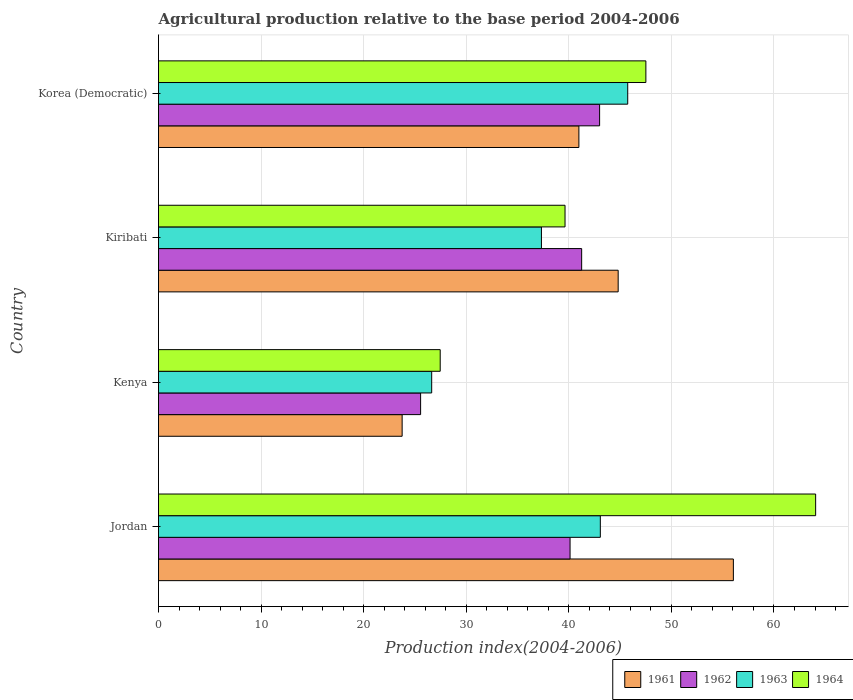How many groups of bars are there?
Give a very brief answer. 4. Are the number of bars on each tick of the Y-axis equal?
Keep it short and to the point. Yes. How many bars are there on the 4th tick from the top?
Provide a short and direct response. 4. What is the label of the 4th group of bars from the top?
Give a very brief answer. Jordan. What is the agricultural production index in 1961 in Kiribati?
Make the answer very short. 44.81. Across all countries, what is the maximum agricultural production index in 1962?
Your answer should be compact. 43. Across all countries, what is the minimum agricultural production index in 1963?
Your response must be concise. 26.63. In which country was the agricultural production index in 1962 maximum?
Make the answer very short. Korea (Democratic). In which country was the agricultural production index in 1962 minimum?
Offer a terse response. Kenya. What is the total agricultural production index in 1964 in the graph?
Your answer should be compact. 178.66. What is the difference between the agricultural production index in 1961 in Jordan and that in Kenya?
Offer a terse response. 32.29. What is the difference between the agricultural production index in 1962 in Kiribati and the agricultural production index in 1964 in Korea (Democratic)?
Provide a short and direct response. -6.26. What is the average agricultural production index in 1961 per country?
Provide a succinct answer. 41.39. What is the difference between the agricultural production index in 1963 and agricultural production index in 1964 in Kiribati?
Your response must be concise. -2.3. In how many countries, is the agricultural production index in 1961 greater than 36 ?
Offer a terse response. 3. What is the ratio of the agricultural production index in 1964 in Kiribati to that in Korea (Democratic)?
Make the answer very short. 0.83. Is the agricultural production index in 1961 in Kenya less than that in Korea (Democratic)?
Provide a short and direct response. Yes. Is the difference between the agricultural production index in 1963 in Kiribati and Korea (Democratic) greater than the difference between the agricultural production index in 1964 in Kiribati and Korea (Democratic)?
Provide a succinct answer. No. What is the difference between the highest and the second highest agricultural production index in 1961?
Make the answer very short. 11.23. What is the difference between the highest and the lowest agricultural production index in 1964?
Provide a short and direct response. 36.6. In how many countries, is the agricultural production index in 1964 greater than the average agricultural production index in 1964 taken over all countries?
Give a very brief answer. 2. Is the sum of the agricultural production index in 1962 in Jordan and Korea (Democratic) greater than the maximum agricultural production index in 1963 across all countries?
Offer a very short reply. Yes. What does the 1st bar from the top in Jordan represents?
Offer a very short reply. 1964. What does the 4th bar from the bottom in Kenya represents?
Give a very brief answer. 1964. Is it the case that in every country, the sum of the agricultural production index in 1961 and agricultural production index in 1963 is greater than the agricultural production index in 1964?
Your answer should be compact. Yes. How many bars are there?
Provide a succinct answer. 16. How many countries are there in the graph?
Offer a terse response. 4. Are the values on the major ticks of X-axis written in scientific E-notation?
Make the answer very short. No. Does the graph contain any zero values?
Provide a succinct answer. No. Does the graph contain grids?
Ensure brevity in your answer.  Yes. Where does the legend appear in the graph?
Keep it short and to the point. Bottom right. How many legend labels are there?
Your answer should be very brief. 4. What is the title of the graph?
Ensure brevity in your answer.  Agricultural production relative to the base period 2004-2006. What is the label or title of the X-axis?
Keep it short and to the point. Production index(2004-2006). What is the label or title of the Y-axis?
Provide a short and direct response. Country. What is the Production index(2004-2006) in 1961 in Jordan?
Provide a succinct answer. 56.04. What is the Production index(2004-2006) of 1962 in Jordan?
Ensure brevity in your answer.  40.12. What is the Production index(2004-2006) of 1963 in Jordan?
Ensure brevity in your answer.  43.07. What is the Production index(2004-2006) of 1964 in Jordan?
Ensure brevity in your answer.  64.06. What is the Production index(2004-2006) in 1961 in Kenya?
Provide a succinct answer. 23.75. What is the Production index(2004-2006) in 1962 in Kenya?
Ensure brevity in your answer.  25.55. What is the Production index(2004-2006) in 1963 in Kenya?
Provide a succinct answer. 26.63. What is the Production index(2004-2006) of 1964 in Kenya?
Your answer should be compact. 27.46. What is the Production index(2004-2006) in 1961 in Kiribati?
Your answer should be very brief. 44.81. What is the Production index(2004-2006) in 1962 in Kiribati?
Your answer should be very brief. 41.25. What is the Production index(2004-2006) in 1963 in Kiribati?
Provide a succinct answer. 37.33. What is the Production index(2004-2006) in 1964 in Kiribati?
Your response must be concise. 39.63. What is the Production index(2004-2006) of 1961 in Korea (Democratic)?
Your response must be concise. 40.98. What is the Production index(2004-2006) of 1963 in Korea (Democratic)?
Your answer should be compact. 45.74. What is the Production index(2004-2006) in 1964 in Korea (Democratic)?
Your response must be concise. 47.51. Across all countries, what is the maximum Production index(2004-2006) of 1961?
Offer a terse response. 56.04. Across all countries, what is the maximum Production index(2004-2006) in 1962?
Offer a very short reply. 43. Across all countries, what is the maximum Production index(2004-2006) of 1963?
Ensure brevity in your answer.  45.74. Across all countries, what is the maximum Production index(2004-2006) in 1964?
Offer a terse response. 64.06. Across all countries, what is the minimum Production index(2004-2006) of 1961?
Offer a terse response. 23.75. Across all countries, what is the minimum Production index(2004-2006) in 1962?
Provide a short and direct response. 25.55. Across all countries, what is the minimum Production index(2004-2006) in 1963?
Ensure brevity in your answer.  26.63. Across all countries, what is the minimum Production index(2004-2006) in 1964?
Make the answer very short. 27.46. What is the total Production index(2004-2006) of 1961 in the graph?
Your response must be concise. 165.58. What is the total Production index(2004-2006) of 1962 in the graph?
Offer a very short reply. 149.92. What is the total Production index(2004-2006) of 1963 in the graph?
Your answer should be compact. 152.77. What is the total Production index(2004-2006) in 1964 in the graph?
Your answer should be compact. 178.66. What is the difference between the Production index(2004-2006) in 1961 in Jordan and that in Kenya?
Your response must be concise. 32.29. What is the difference between the Production index(2004-2006) of 1962 in Jordan and that in Kenya?
Your answer should be compact. 14.57. What is the difference between the Production index(2004-2006) of 1963 in Jordan and that in Kenya?
Ensure brevity in your answer.  16.44. What is the difference between the Production index(2004-2006) of 1964 in Jordan and that in Kenya?
Ensure brevity in your answer.  36.6. What is the difference between the Production index(2004-2006) in 1961 in Jordan and that in Kiribati?
Make the answer very short. 11.23. What is the difference between the Production index(2004-2006) of 1962 in Jordan and that in Kiribati?
Your answer should be compact. -1.13. What is the difference between the Production index(2004-2006) in 1963 in Jordan and that in Kiribati?
Offer a very short reply. 5.74. What is the difference between the Production index(2004-2006) in 1964 in Jordan and that in Kiribati?
Keep it short and to the point. 24.43. What is the difference between the Production index(2004-2006) in 1961 in Jordan and that in Korea (Democratic)?
Your response must be concise. 15.06. What is the difference between the Production index(2004-2006) of 1962 in Jordan and that in Korea (Democratic)?
Offer a very short reply. -2.88. What is the difference between the Production index(2004-2006) of 1963 in Jordan and that in Korea (Democratic)?
Give a very brief answer. -2.67. What is the difference between the Production index(2004-2006) of 1964 in Jordan and that in Korea (Democratic)?
Give a very brief answer. 16.55. What is the difference between the Production index(2004-2006) of 1961 in Kenya and that in Kiribati?
Offer a terse response. -21.06. What is the difference between the Production index(2004-2006) of 1962 in Kenya and that in Kiribati?
Ensure brevity in your answer.  -15.7. What is the difference between the Production index(2004-2006) in 1964 in Kenya and that in Kiribati?
Offer a terse response. -12.17. What is the difference between the Production index(2004-2006) of 1961 in Kenya and that in Korea (Democratic)?
Offer a very short reply. -17.23. What is the difference between the Production index(2004-2006) of 1962 in Kenya and that in Korea (Democratic)?
Your answer should be compact. -17.45. What is the difference between the Production index(2004-2006) in 1963 in Kenya and that in Korea (Democratic)?
Keep it short and to the point. -19.11. What is the difference between the Production index(2004-2006) of 1964 in Kenya and that in Korea (Democratic)?
Your response must be concise. -20.05. What is the difference between the Production index(2004-2006) in 1961 in Kiribati and that in Korea (Democratic)?
Provide a succinct answer. 3.83. What is the difference between the Production index(2004-2006) of 1962 in Kiribati and that in Korea (Democratic)?
Your answer should be compact. -1.75. What is the difference between the Production index(2004-2006) in 1963 in Kiribati and that in Korea (Democratic)?
Ensure brevity in your answer.  -8.41. What is the difference between the Production index(2004-2006) in 1964 in Kiribati and that in Korea (Democratic)?
Keep it short and to the point. -7.88. What is the difference between the Production index(2004-2006) in 1961 in Jordan and the Production index(2004-2006) in 1962 in Kenya?
Your response must be concise. 30.49. What is the difference between the Production index(2004-2006) of 1961 in Jordan and the Production index(2004-2006) of 1963 in Kenya?
Offer a terse response. 29.41. What is the difference between the Production index(2004-2006) in 1961 in Jordan and the Production index(2004-2006) in 1964 in Kenya?
Make the answer very short. 28.58. What is the difference between the Production index(2004-2006) of 1962 in Jordan and the Production index(2004-2006) of 1963 in Kenya?
Make the answer very short. 13.49. What is the difference between the Production index(2004-2006) in 1962 in Jordan and the Production index(2004-2006) in 1964 in Kenya?
Keep it short and to the point. 12.66. What is the difference between the Production index(2004-2006) in 1963 in Jordan and the Production index(2004-2006) in 1964 in Kenya?
Your response must be concise. 15.61. What is the difference between the Production index(2004-2006) in 1961 in Jordan and the Production index(2004-2006) in 1962 in Kiribati?
Provide a short and direct response. 14.79. What is the difference between the Production index(2004-2006) of 1961 in Jordan and the Production index(2004-2006) of 1963 in Kiribati?
Provide a succinct answer. 18.71. What is the difference between the Production index(2004-2006) in 1961 in Jordan and the Production index(2004-2006) in 1964 in Kiribati?
Offer a terse response. 16.41. What is the difference between the Production index(2004-2006) in 1962 in Jordan and the Production index(2004-2006) in 1963 in Kiribati?
Your answer should be compact. 2.79. What is the difference between the Production index(2004-2006) of 1962 in Jordan and the Production index(2004-2006) of 1964 in Kiribati?
Keep it short and to the point. 0.49. What is the difference between the Production index(2004-2006) in 1963 in Jordan and the Production index(2004-2006) in 1964 in Kiribati?
Ensure brevity in your answer.  3.44. What is the difference between the Production index(2004-2006) in 1961 in Jordan and the Production index(2004-2006) in 1962 in Korea (Democratic)?
Offer a terse response. 13.04. What is the difference between the Production index(2004-2006) in 1961 in Jordan and the Production index(2004-2006) in 1963 in Korea (Democratic)?
Make the answer very short. 10.3. What is the difference between the Production index(2004-2006) of 1961 in Jordan and the Production index(2004-2006) of 1964 in Korea (Democratic)?
Keep it short and to the point. 8.53. What is the difference between the Production index(2004-2006) of 1962 in Jordan and the Production index(2004-2006) of 1963 in Korea (Democratic)?
Give a very brief answer. -5.62. What is the difference between the Production index(2004-2006) of 1962 in Jordan and the Production index(2004-2006) of 1964 in Korea (Democratic)?
Keep it short and to the point. -7.39. What is the difference between the Production index(2004-2006) of 1963 in Jordan and the Production index(2004-2006) of 1964 in Korea (Democratic)?
Your response must be concise. -4.44. What is the difference between the Production index(2004-2006) of 1961 in Kenya and the Production index(2004-2006) of 1962 in Kiribati?
Your response must be concise. -17.5. What is the difference between the Production index(2004-2006) of 1961 in Kenya and the Production index(2004-2006) of 1963 in Kiribati?
Your answer should be very brief. -13.58. What is the difference between the Production index(2004-2006) in 1961 in Kenya and the Production index(2004-2006) in 1964 in Kiribati?
Provide a short and direct response. -15.88. What is the difference between the Production index(2004-2006) in 1962 in Kenya and the Production index(2004-2006) in 1963 in Kiribati?
Offer a very short reply. -11.78. What is the difference between the Production index(2004-2006) of 1962 in Kenya and the Production index(2004-2006) of 1964 in Kiribati?
Offer a terse response. -14.08. What is the difference between the Production index(2004-2006) in 1963 in Kenya and the Production index(2004-2006) in 1964 in Kiribati?
Ensure brevity in your answer.  -13. What is the difference between the Production index(2004-2006) in 1961 in Kenya and the Production index(2004-2006) in 1962 in Korea (Democratic)?
Offer a terse response. -19.25. What is the difference between the Production index(2004-2006) in 1961 in Kenya and the Production index(2004-2006) in 1963 in Korea (Democratic)?
Provide a succinct answer. -21.99. What is the difference between the Production index(2004-2006) in 1961 in Kenya and the Production index(2004-2006) in 1964 in Korea (Democratic)?
Ensure brevity in your answer.  -23.76. What is the difference between the Production index(2004-2006) of 1962 in Kenya and the Production index(2004-2006) of 1963 in Korea (Democratic)?
Make the answer very short. -20.19. What is the difference between the Production index(2004-2006) of 1962 in Kenya and the Production index(2004-2006) of 1964 in Korea (Democratic)?
Offer a terse response. -21.96. What is the difference between the Production index(2004-2006) in 1963 in Kenya and the Production index(2004-2006) in 1964 in Korea (Democratic)?
Your answer should be compact. -20.88. What is the difference between the Production index(2004-2006) in 1961 in Kiribati and the Production index(2004-2006) in 1962 in Korea (Democratic)?
Offer a terse response. 1.81. What is the difference between the Production index(2004-2006) of 1961 in Kiribati and the Production index(2004-2006) of 1963 in Korea (Democratic)?
Your answer should be very brief. -0.93. What is the difference between the Production index(2004-2006) of 1962 in Kiribati and the Production index(2004-2006) of 1963 in Korea (Democratic)?
Keep it short and to the point. -4.49. What is the difference between the Production index(2004-2006) of 1962 in Kiribati and the Production index(2004-2006) of 1964 in Korea (Democratic)?
Offer a very short reply. -6.26. What is the difference between the Production index(2004-2006) in 1963 in Kiribati and the Production index(2004-2006) in 1964 in Korea (Democratic)?
Offer a very short reply. -10.18. What is the average Production index(2004-2006) of 1961 per country?
Ensure brevity in your answer.  41.4. What is the average Production index(2004-2006) in 1962 per country?
Keep it short and to the point. 37.48. What is the average Production index(2004-2006) in 1963 per country?
Ensure brevity in your answer.  38.19. What is the average Production index(2004-2006) in 1964 per country?
Provide a succinct answer. 44.66. What is the difference between the Production index(2004-2006) of 1961 and Production index(2004-2006) of 1962 in Jordan?
Give a very brief answer. 15.92. What is the difference between the Production index(2004-2006) of 1961 and Production index(2004-2006) of 1963 in Jordan?
Your answer should be compact. 12.97. What is the difference between the Production index(2004-2006) of 1961 and Production index(2004-2006) of 1964 in Jordan?
Make the answer very short. -8.02. What is the difference between the Production index(2004-2006) in 1962 and Production index(2004-2006) in 1963 in Jordan?
Make the answer very short. -2.95. What is the difference between the Production index(2004-2006) in 1962 and Production index(2004-2006) in 1964 in Jordan?
Keep it short and to the point. -23.94. What is the difference between the Production index(2004-2006) of 1963 and Production index(2004-2006) of 1964 in Jordan?
Give a very brief answer. -20.99. What is the difference between the Production index(2004-2006) in 1961 and Production index(2004-2006) in 1963 in Kenya?
Your answer should be very brief. -2.88. What is the difference between the Production index(2004-2006) of 1961 and Production index(2004-2006) of 1964 in Kenya?
Your response must be concise. -3.71. What is the difference between the Production index(2004-2006) in 1962 and Production index(2004-2006) in 1963 in Kenya?
Your answer should be very brief. -1.08. What is the difference between the Production index(2004-2006) in 1962 and Production index(2004-2006) in 1964 in Kenya?
Your response must be concise. -1.91. What is the difference between the Production index(2004-2006) in 1963 and Production index(2004-2006) in 1964 in Kenya?
Ensure brevity in your answer.  -0.83. What is the difference between the Production index(2004-2006) of 1961 and Production index(2004-2006) of 1962 in Kiribati?
Your response must be concise. 3.56. What is the difference between the Production index(2004-2006) in 1961 and Production index(2004-2006) in 1963 in Kiribati?
Provide a succinct answer. 7.48. What is the difference between the Production index(2004-2006) in 1961 and Production index(2004-2006) in 1964 in Kiribati?
Make the answer very short. 5.18. What is the difference between the Production index(2004-2006) of 1962 and Production index(2004-2006) of 1963 in Kiribati?
Offer a terse response. 3.92. What is the difference between the Production index(2004-2006) in 1962 and Production index(2004-2006) in 1964 in Kiribati?
Your answer should be very brief. 1.62. What is the difference between the Production index(2004-2006) of 1961 and Production index(2004-2006) of 1962 in Korea (Democratic)?
Offer a very short reply. -2.02. What is the difference between the Production index(2004-2006) in 1961 and Production index(2004-2006) in 1963 in Korea (Democratic)?
Your response must be concise. -4.76. What is the difference between the Production index(2004-2006) of 1961 and Production index(2004-2006) of 1964 in Korea (Democratic)?
Provide a short and direct response. -6.53. What is the difference between the Production index(2004-2006) in 1962 and Production index(2004-2006) in 1963 in Korea (Democratic)?
Make the answer very short. -2.74. What is the difference between the Production index(2004-2006) of 1962 and Production index(2004-2006) of 1964 in Korea (Democratic)?
Provide a short and direct response. -4.51. What is the difference between the Production index(2004-2006) of 1963 and Production index(2004-2006) of 1964 in Korea (Democratic)?
Keep it short and to the point. -1.77. What is the ratio of the Production index(2004-2006) in 1961 in Jordan to that in Kenya?
Your response must be concise. 2.36. What is the ratio of the Production index(2004-2006) in 1962 in Jordan to that in Kenya?
Make the answer very short. 1.57. What is the ratio of the Production index(2004-2006) in 1963 in Jordan to that in Kenya?
Give a very brief answer. 1.62. What is the ratio of the Production index(2004-2006) of 1964 in Jordan to that in Kenya?
Your answer should be compact. 2.33. What is the ratio of the Production index(2004-2006) of 1961 in Jordan to that in Kiribati?
Your answer should be compact. 1.25. What is the ratio of the Production index(2004-2006) of 1962 in Jordan to that in Kiribati?
Your answer should be very brief. 0.97. What is the ratio of the Production index(2004-2006) in 1963 in Jordan to that in Kiribati?
Provide a succinct answer. 1.15. What is the ratio of the Production index(2004-2006) of 1964 in Jordan to that in Kiribati?
Provide a short and direct response. 1.62. What is the ratio of the Production index(2004-2006) of 1961 in Jordan to that in Korea (Democratic)?
Your answer should be compact. 1.37. What is the ratio of the Production index(2004-2006) in 1962 in Jordan to that in Korea (Democratic)?
Give a very brief answer. 0.93. What is the ratio of the Production index(2004-2006) of 1963 in Jordan to that in Korea (Democratic)?
Your answer should be compact. 0.94. What is the ratio of the Production index(2004-2006) in 1964 in Jordan to that in Korea (Democratic)?
Your response must be concise. 1.35. What is the ratio of the Production index(2004-2006) in 1961 in Kenya to that in Kiribati?
Provide a short and direct response. 0.53. What is the ratio of the Production index(2004-2006) of 1962 in Kenya to that in Kiribati?
Offer a very short reply. 0.62. What is the ratio of the Production index(2004-2006) of 1963 in Kenya to that in Kiribati?
Give a very brief answer. 0.71. What is the ratio of the Production index(2004-2006) in 1964 in Kenya to that in Kiribati?
Ensure brevity in your answer.  0.69. What is the ratio of the Production index(2004-2006) in 1961 in Kenya to that in Korea (Democratic)?
Your response must be concise. 0.58. What is the ratio of the Production index(2004-2006) in 1962 in Kenya to that in Korea (Democratic)?
Give a very brief answer. 0.59. What is the ratio of the Production index(2004-2006) of 1963 in Kenya to that in Korea (Democratic)?
Your answer should be very brief. 0.58. What is the ratio of the Production index(2004-2006) of 1964 in Kenya to that in Korea (Democratic)?
Ensure brevity in your answer.  0.58. What is the ratio of the Production index(2004-2006) of 1961 in Kiribati to that in Korea (Democratic)?
Ensure brevity in your answer.  1.09. What is the ratio of the Production index(2004-2006) of 1962 in Kiribati to that in Korea (Democratic)?
Your answer should be compact. 0.96. What is the ratio of the Production index(2004-2006) of 1963 in Kiribati to that in Korea (Democratic)?
Provide a succinct answer. 0.82. What is the ratio of the Production index(2004-2006) in 1964 in Kiribati to that in Korea (Democratic)?
Offer a terse response. 0.83. What is the difference between the highest and the second highest Production index(2004-2006) in 1961?
Offer a very short reply. 11.23. What is the difference between the highest and the second highest Production index(2004-2006) of 1962?
Keep it short and to the point. 1.75. What is the difference between the highest and the second highest Production index(2004-2006) of 1963?
Ensure brevity in your answer.  2.67. What is the difference between the highest and the second highest Production index(2004-2006) of 1964?
Ensure brevity in your answer.  16.55. What is the difference between the highest and the lowest Production index(2004-2006) in 1961?
Give a very brief answer. 32.29. What is the difference between the highest and the lowest Production index(2004-2006) in 1962?
Keep it short and to the point. 17.45. What is the difference between the highest and the lowest Production index(2004-2006) of 1963?
Provide a succinct answer. 19.11. What is the difference between the highest and the lowest Production index(2004-2006) of 1964?
Provide a succinct answer. 36.6. 